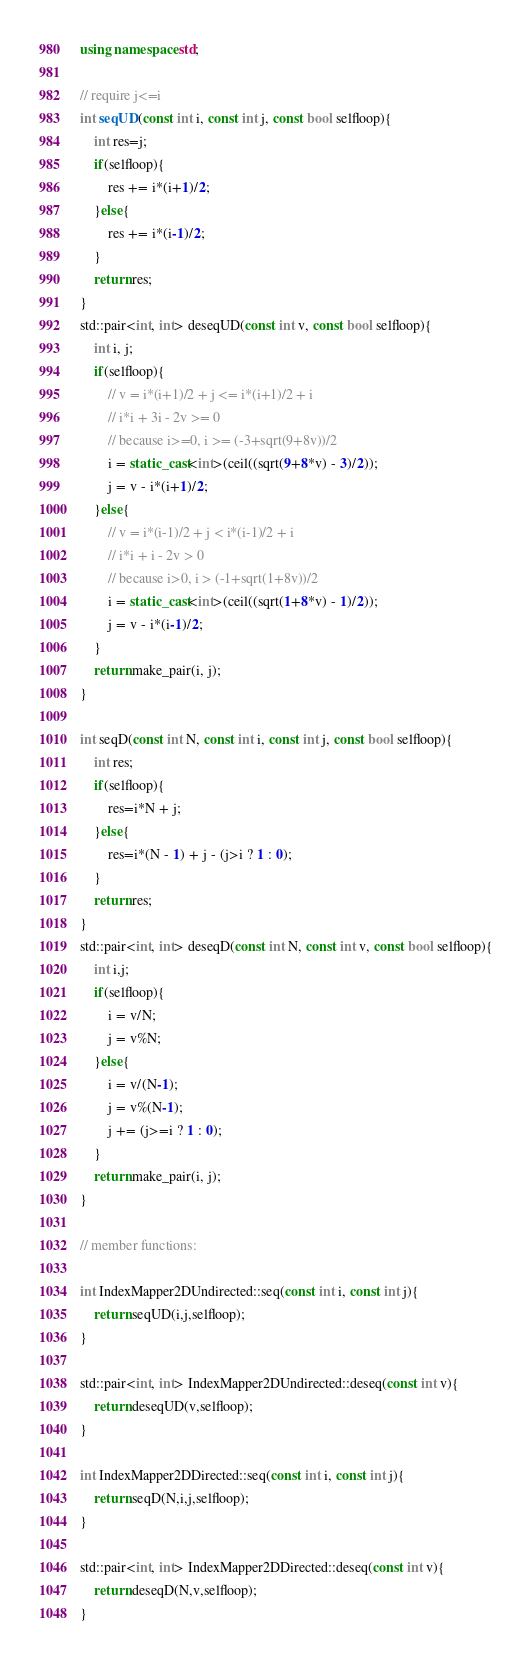Convert code to text. <code><loc_0><loc_0><loc_500><loc_500><_C++_>
using namespace std;

// require j<=i
int seqUD(const int i, const int j, const bool selfloop){
    int res=j;
    if(selfloop){
        res += i*(i+1)/2;
    }else{
        res += i*(i-1)/2;
    }
    return res;
}
std::pair<int, int> deseqUD(const int v, const bool selfloop){
    int i, j;
    if(selfloop){
        // v = i*(i+1)/2 + j <= i*(i+1)/2 + i
        // i*i + 3i - 2v >= 0
        // because i>=0, i >= (-3+sqrt(9+8v))/2
        i = static_cast<int>(ceil((sqrt(9+8*v) - 3)/2));
        j = v - i*(i+1)/2;
    }else{
        // v = i*(i-1)/2 + j < i*(i-1)/2 + i
        // i*i + i - 2v > 0
        // because i>0, i > (-1+sqrt(1+8v))/2
        i = static_cast<int>(ceil((sqrt(1+8*v) - 1)/2));
        j = v - i*(i-1)/2;
    }
    return make_pair(i, j);
}

int seqD(const int N, const int i, const int j, const bool selfloop){
    int res;
    if(selfloop){
        res=i*N + j;
    }else{
        res=i*(N - 1) + j - (j>i ? 1 : 0);
    }
    return res;
}
std::pair<int, int> deseqD(const int N, const int v, const bool selfloop){
    int i,j;
    if(selfloop){
        i = v/N;
        j = v%N;
    }else{
        i = v/(N-1);
        j = v%(N-1);
        j += (j>=i ? 1 : 0);
    }
    return make_pair(i, j);
}

// member functions: 

int IndexMapper2DUndirected::seq(const int i, const int j){
    return seqUD(i,j,selfloop);
}

std::pair<int, int> IndexMapper2DUndirected::deseq(const int v){
    return deseqUD(v,selfloop);
}

int IndexMapper2DDirected::seq(const int i, const int j){
    return seqD(N,i,j,selfloop);
}

std::pair<int, int> IndexMapper2DDirected::deseq(const int v){
    return deseqD(N,v,selfloop);
}
</code> 